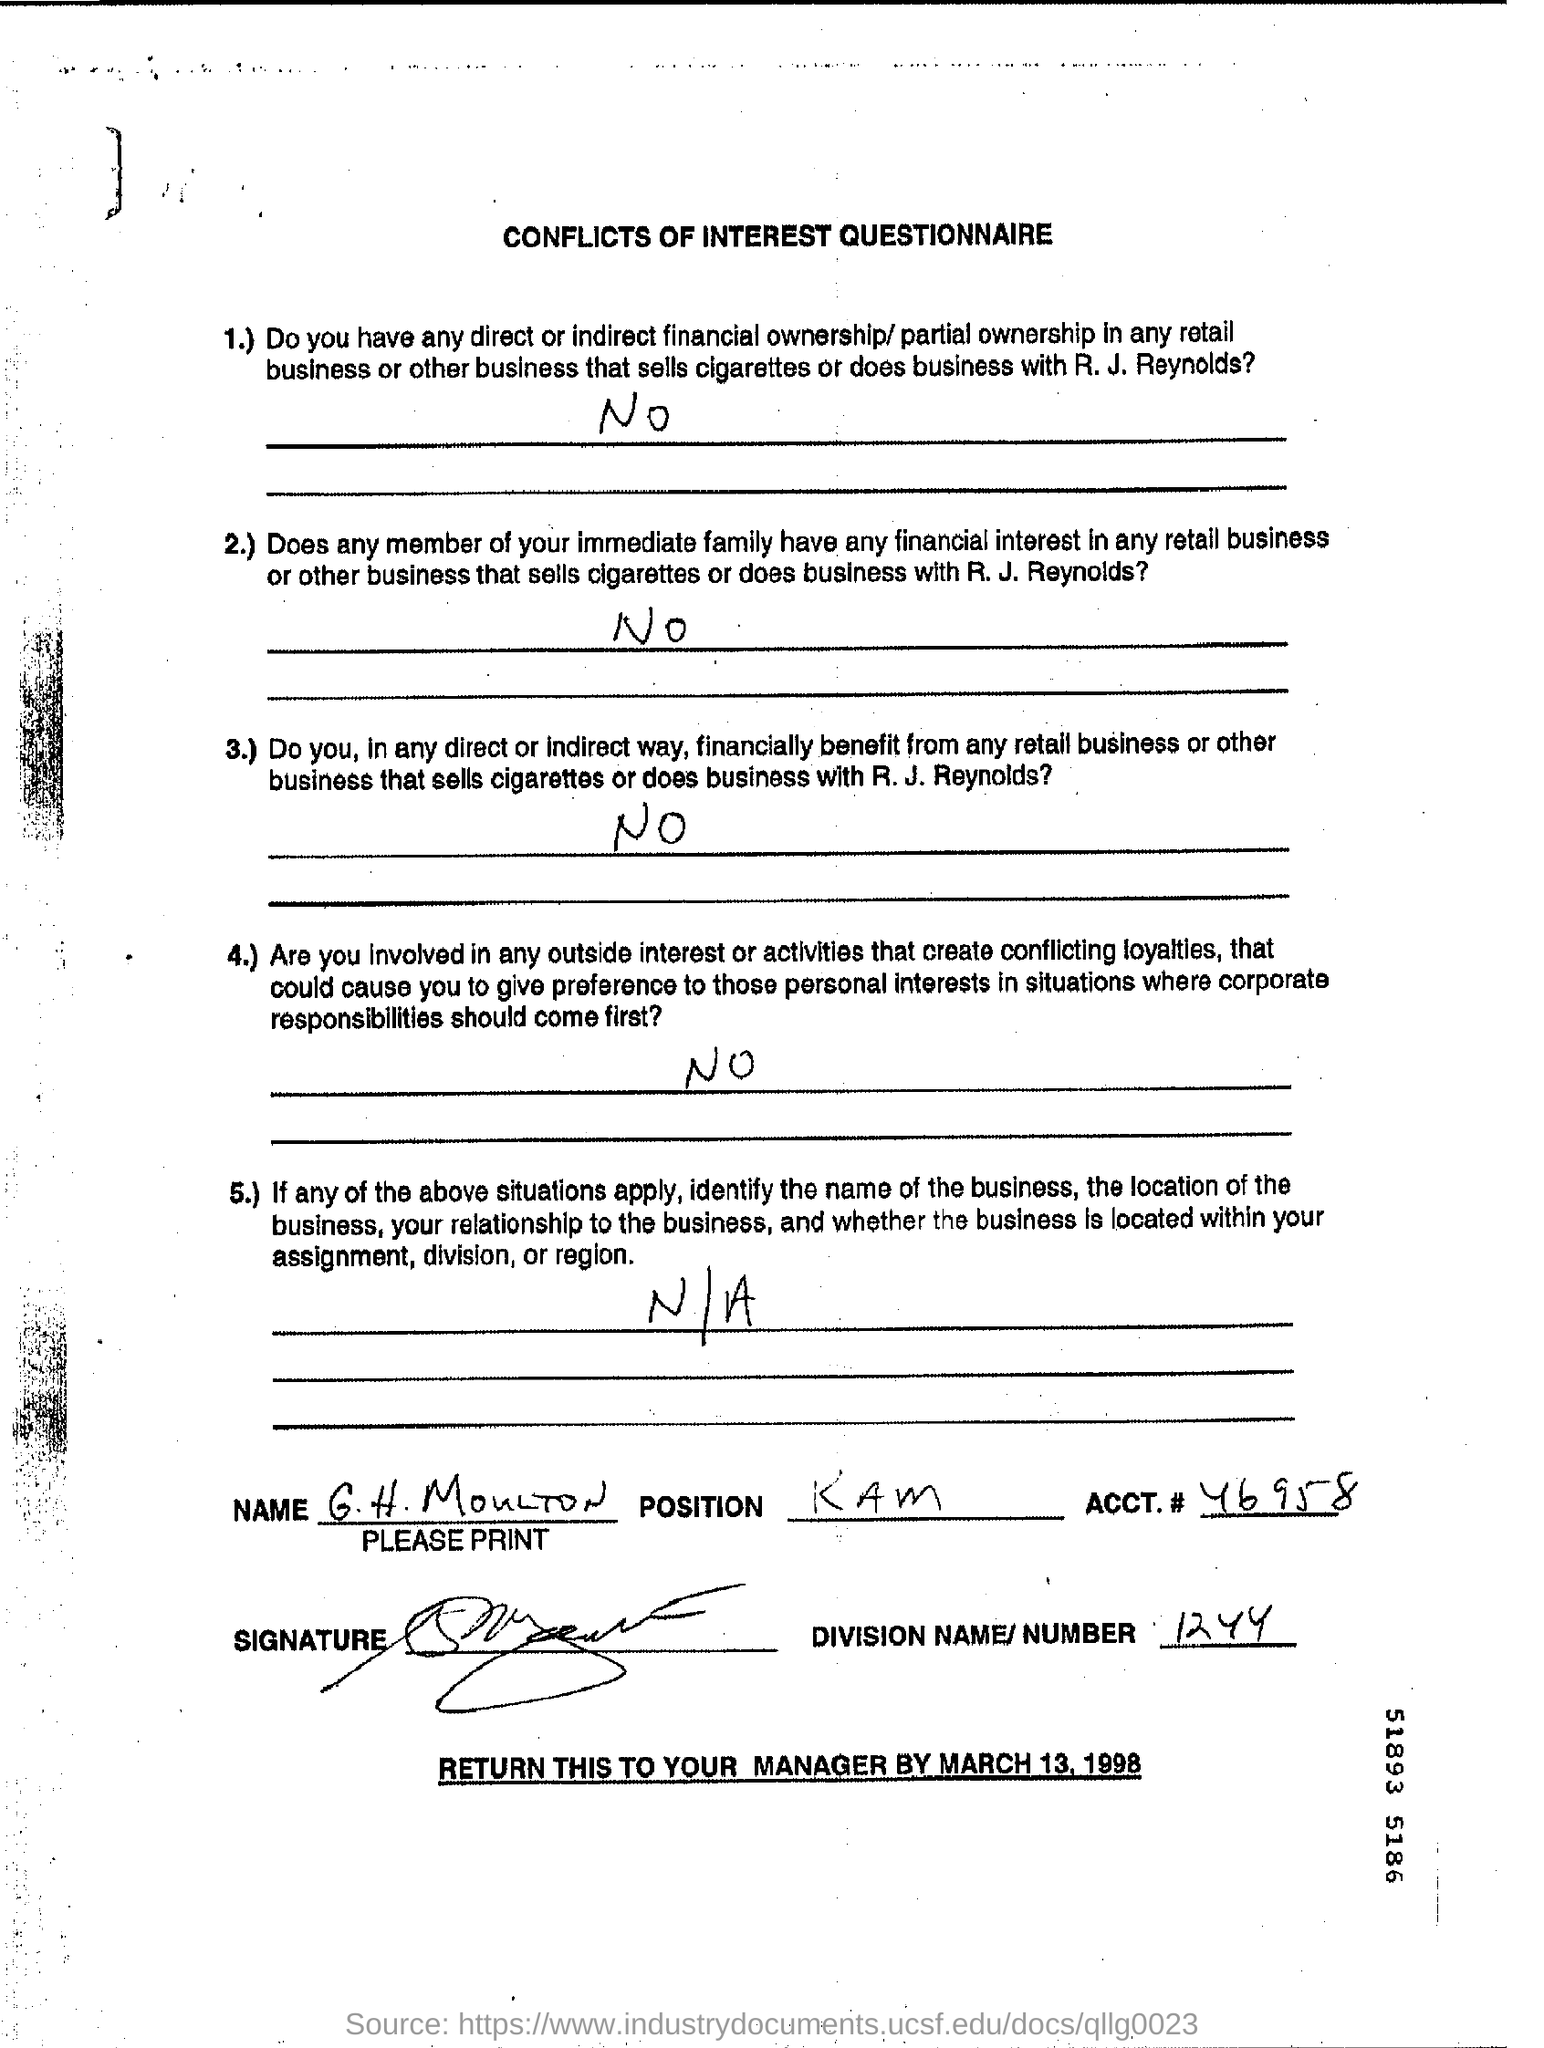What is the ACCT.#?
Give a very brief answer. 46958. What is the Division Name/Number?
Offer a very short reply. 1244. What is the Position?
Your answer should be compact. KAM. 